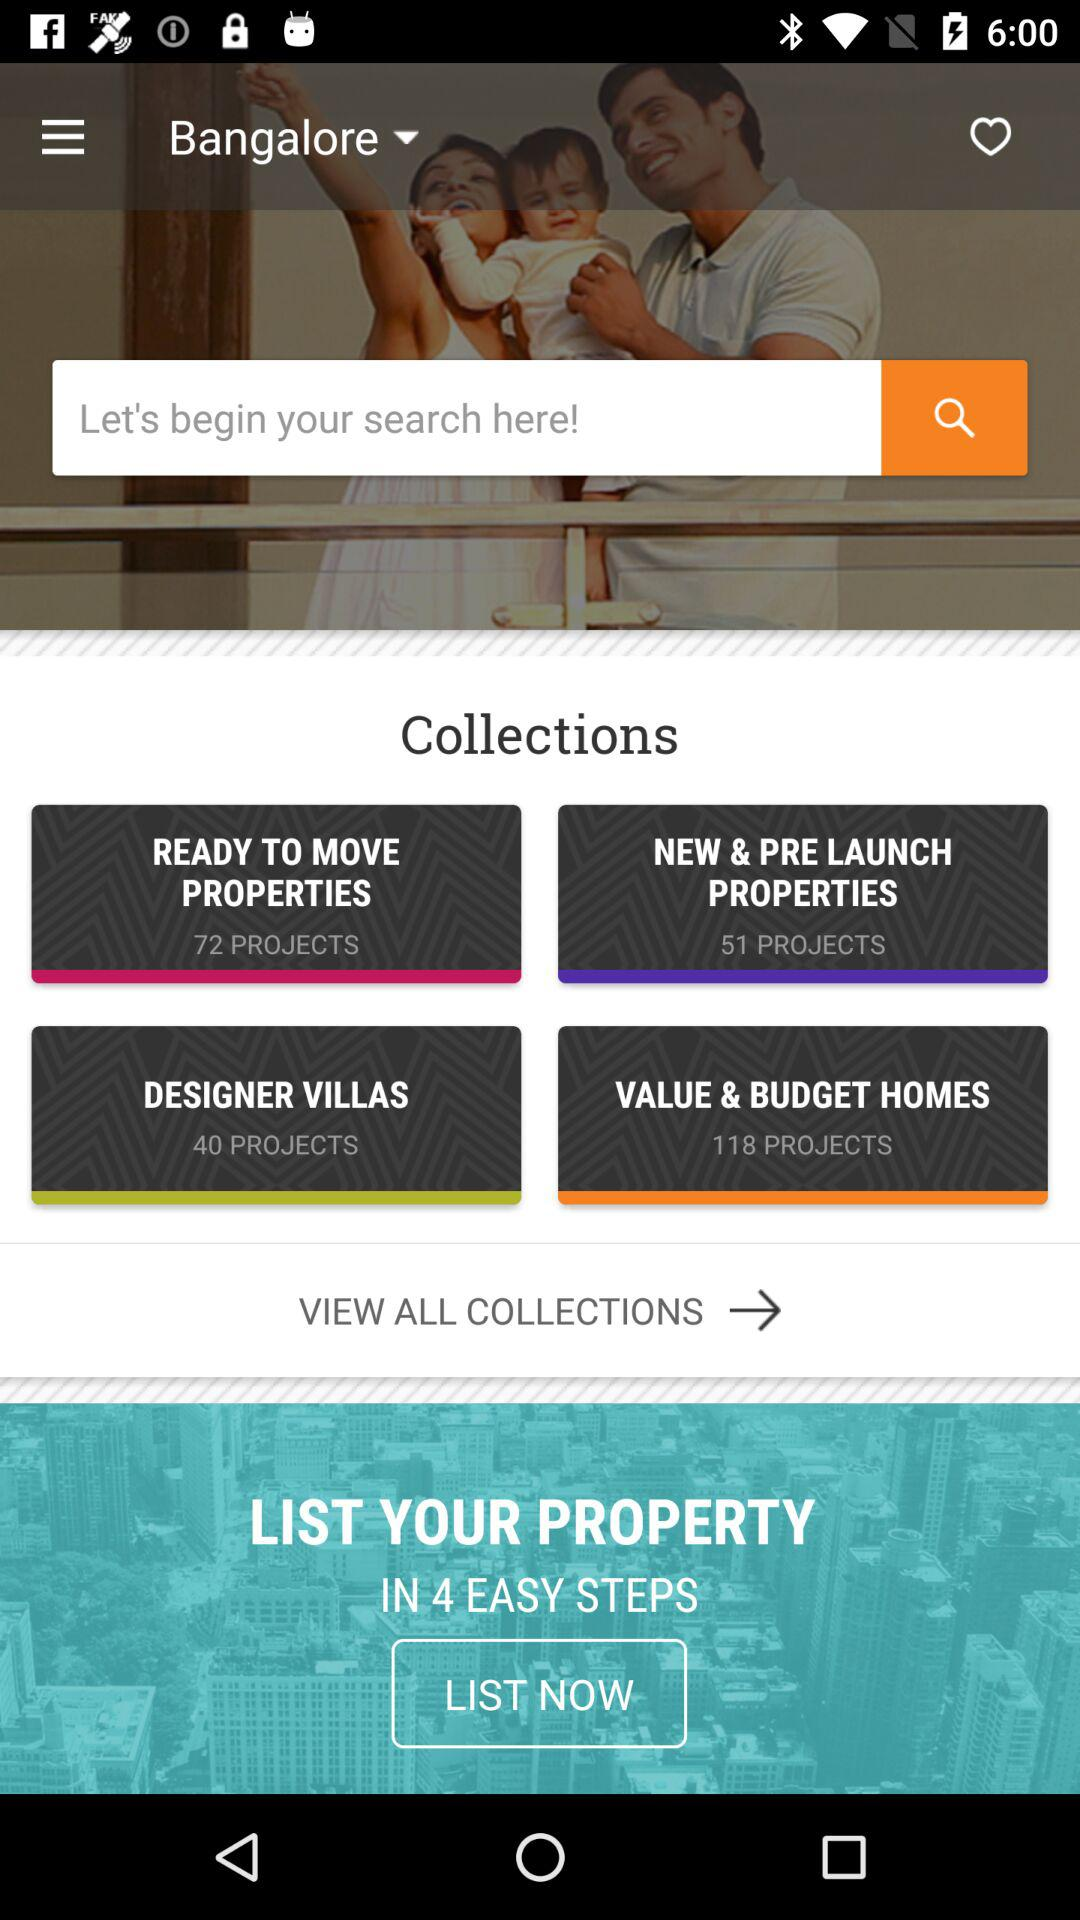How many ready to move properties are there? There are 72 ready-to-move properties. 